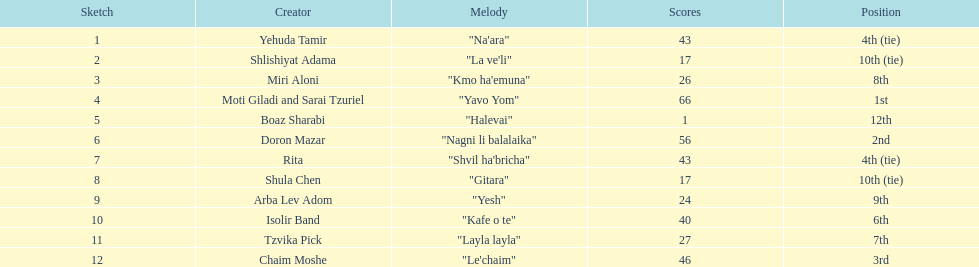Did the song "gitara" or "yesh" earn more points? "Yesh". 